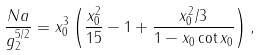Convert formula to latex. <formula><loc_0><loc_0><loc_500><loc_500>\frac { N a } { g _ { 2 } ^ { 5 / 2 } } = x _ { 0 } ^ { 3 } \left ( \frac { x _ { 0 } ^ { 2 } } { 1 5 } - 1 + \frac { x _ { 0 } ^ { 2 } / 3 } { 1 - x _ { 0 } \cot x _ { 0 } } \right ) ,</formula> 